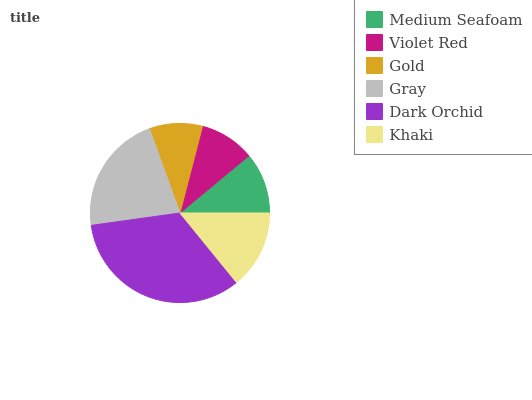Is Gold the minimum?
Answer yes or no. Yes. Is Dark Orchid the maximum?
Answer yes or no. Yes. Is Violet Red the minimum?
Answer yes or no. No. Is Violet Red the maximum?
Answer yes or no. No. Is Medium Seafoam greater than Violet Red?
Answer yes or no. Yes. Is Violet Red less than Medium Seafoam?
Answer yes or no. Yes. Is Violet Red greater than Medium Seafoam?
Answer yes or no. No. Is Medium Seafoam less than Violet Red?
Answer yes or no. No. Is Khaki the high median?
Answer yes or no. Yes. Is Medium Seafoam the low median?
Answer yes or no. Yes. Is Medium Seafoam the high median?
Answer yes or no. No. Is Violet Red the low median?
Answer yes or no. No. 